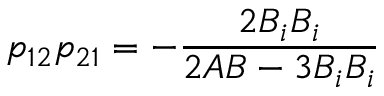Convert formula to latex. <formula><loc_0><loc_0><loc_500><loc_500>p _ { 1 2 } p _ { 2 1 } = - \frac { 2 B _ { i } B _ { i } } { 2 A B - 3 B _ { i } B _ { i } }</formula> 